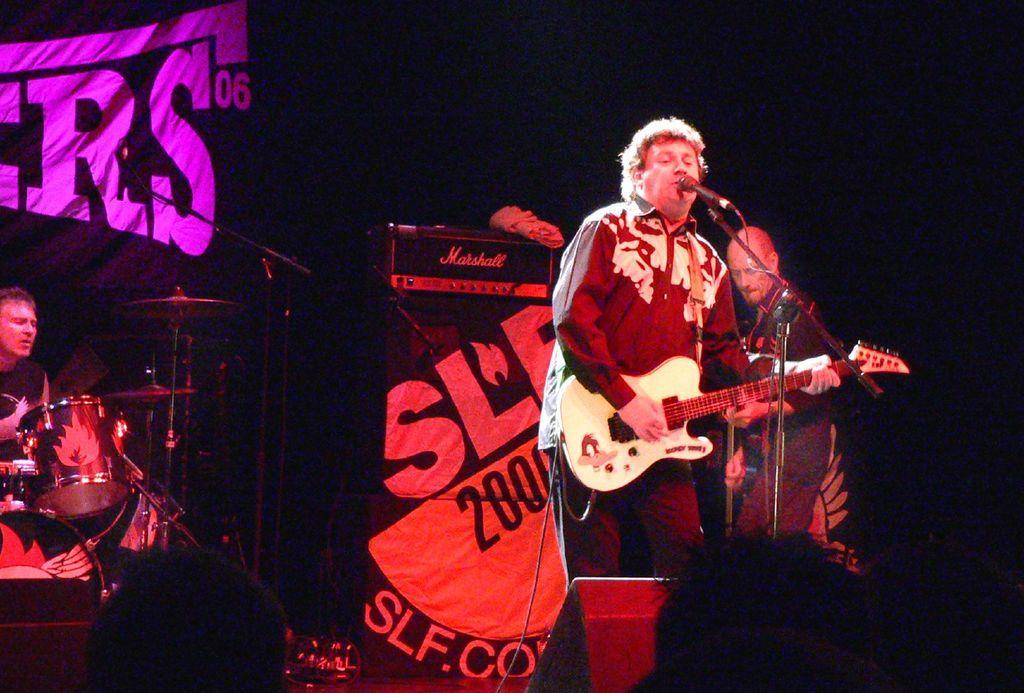Can you describe this image briefly? Background is very dark. Herre we can see two persons standing in front of a mike and playing guitar. One man is sitting and playing drums. 